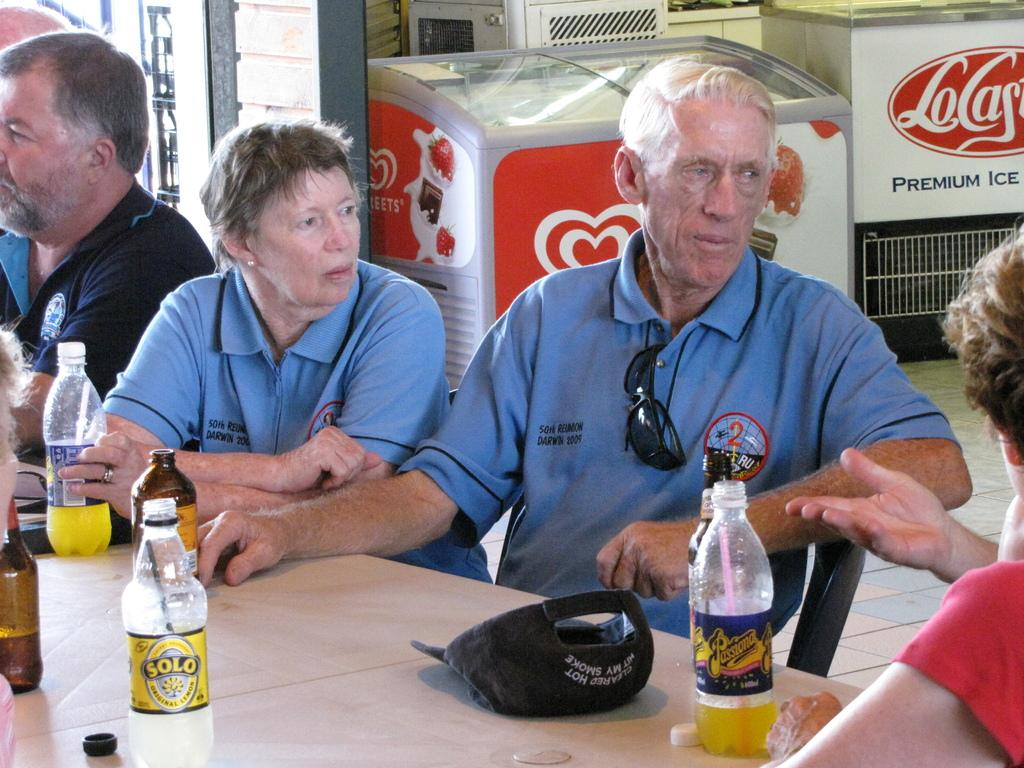How many people are sitting in the image? There are four people sitting in the image. What are the people sitting in front of? The people are sitting in front of a table. What object can be seen on the table? There is a cap and bottles on the table. What can be seen in the background of the image? There is a fridge in the background of the image. What time is displayed on the clock in the image? There is no clock present in the image. What type of trousers are the people wearing in the image? The provided facts do not mention the type of trousers the people are wearing. 